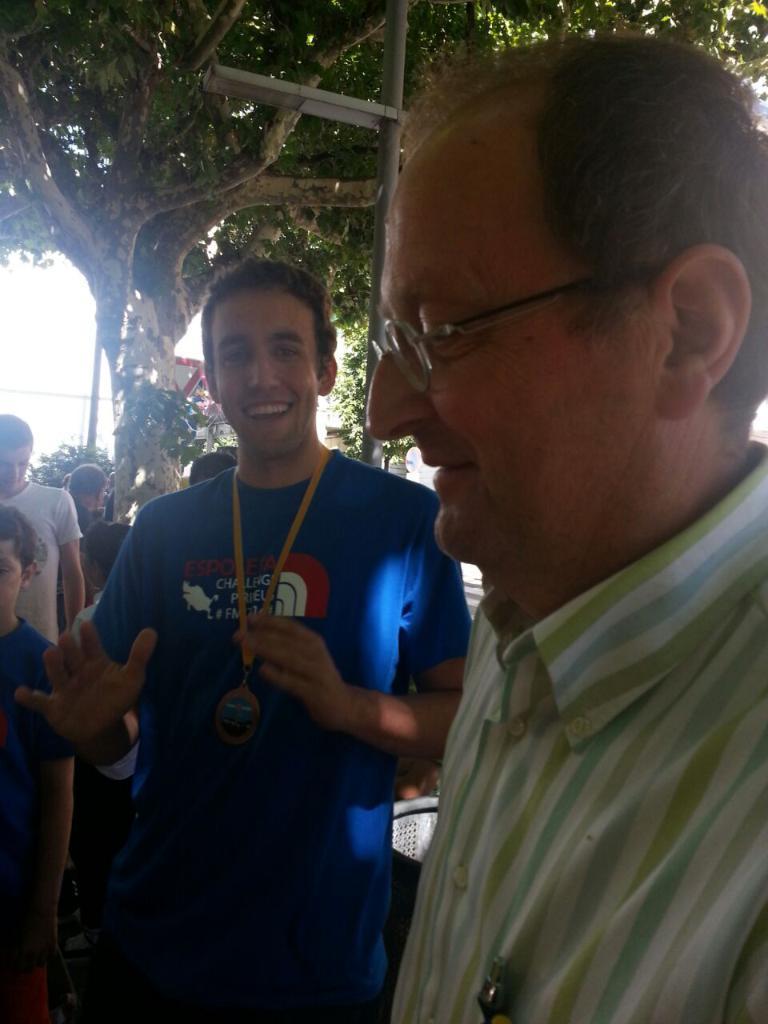Can you describe this image briefly? In this image in front there are two people wearing a smile on their faces. Behind them there are a few other people. In the background of the image there are trees. There are poles, boards and sky. 